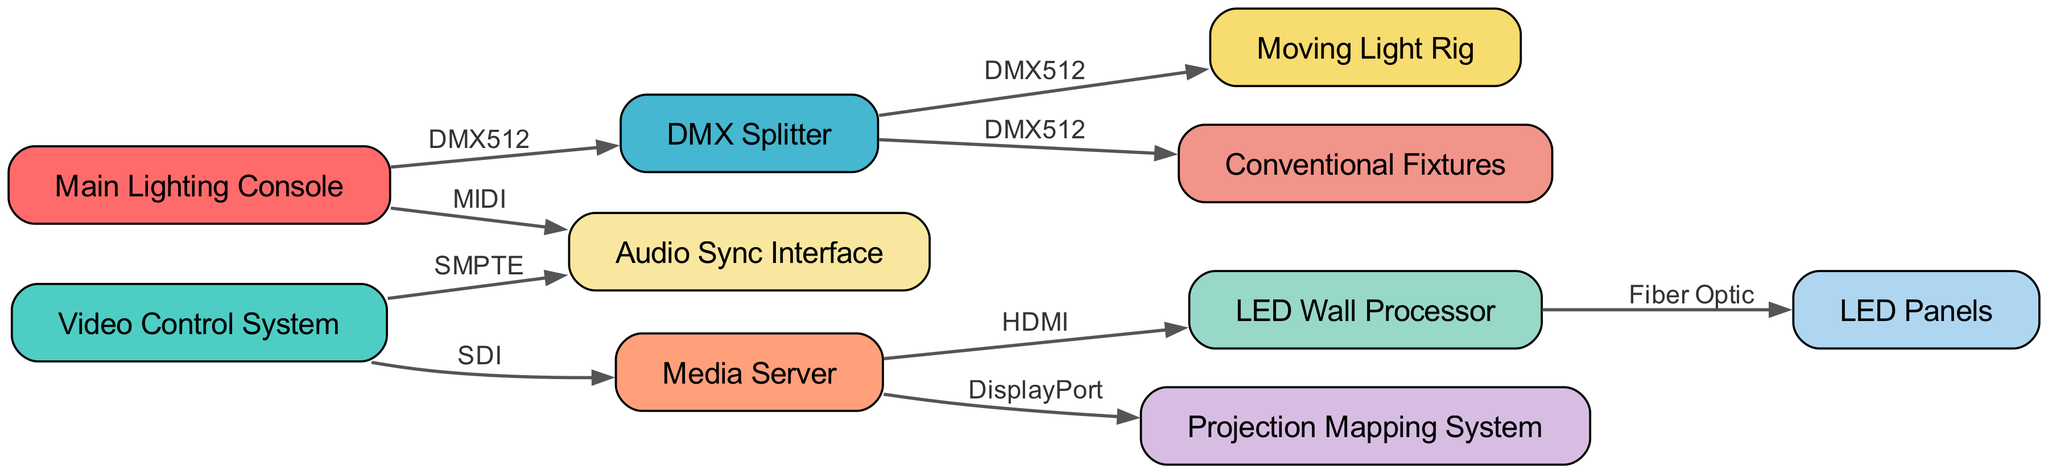What is the total number of nodes in the diagram? The diagram contains a total of ten nodes, which are listed individually: Main Lighting Console, Video Control System, DMX Splitter, Media Server, LED Wall Processor, Moving Light Rig, Conventional Fixtures, LED Panels, Projection Mapping System, and Audio Sync Interface. Counting these gives a total of 10.
Answer: 10 Which node is connected to both the Main Lighting Console and the Audio Sync Interface? Looking at the connections in the diagram, the Main Lighting Console connects to two nodes: DMX Splitter and Audio Sync Interface. The node that connects to the Audio Sync Interface, directly coming from the Main Lighting Console, is the Audio Sync Interface itself. Hence, the answer is Audio Sync Interface.
Answer: Audio Sync Interface How many edges originate from the DMX Splitter? The DMX Splitter has two outgoing edges: one to the Moving Light Rig and the other to the Conventional Fixtures. By counting these connections, we determine that there are 2 edges originating from the DMX Splitter.
Answer: 2 What connection type is used between the Video Control System and the Media Server? The connection between the Video Control System and the Media Server is labeled SDI. This label directly identifies the nature of the signal routing used in this specific connection.
Answer: SDI Identify the node that receives a connection from the Media Server other than the LED Wall Processor. The Media Server also connects to the Projection Mapping System, as seen in the diagram. This connection utilizes the DisplayPort type. Thus, excluding the LED Wall Processor, the other node receiving a connection from the Media Server is the Projection Mapping System.
Answer: Projection Mapping System Which fixtures are routed through DMX512 in the diagram? Both the Moving Light Rig and Conventional Fixtures receive signals routed through DMX512 from the DMX Splitter, as indicated on the edges in the diagram. Specifically, the outgoing connections to both of these nodes are labeled DMX512.
Answer: Moving Light Rig, Conventional Fixtures What is the total number of unique connection types displayed in the diagram? There are three unique connection types shown in the diagram: DMX512, SDI, and HDMI. By analyzing the edges and their labels, we can confirm that there are no additional connection types beyond these three.
Answer: 3 Which node is responsible for controlling the video and is connected via SDI? The Video Control System is responsible for controlling the video and is connected to the Media Server through the SDI connection. This connection indicates the video routing path in the system.
Answer: Video Control System 